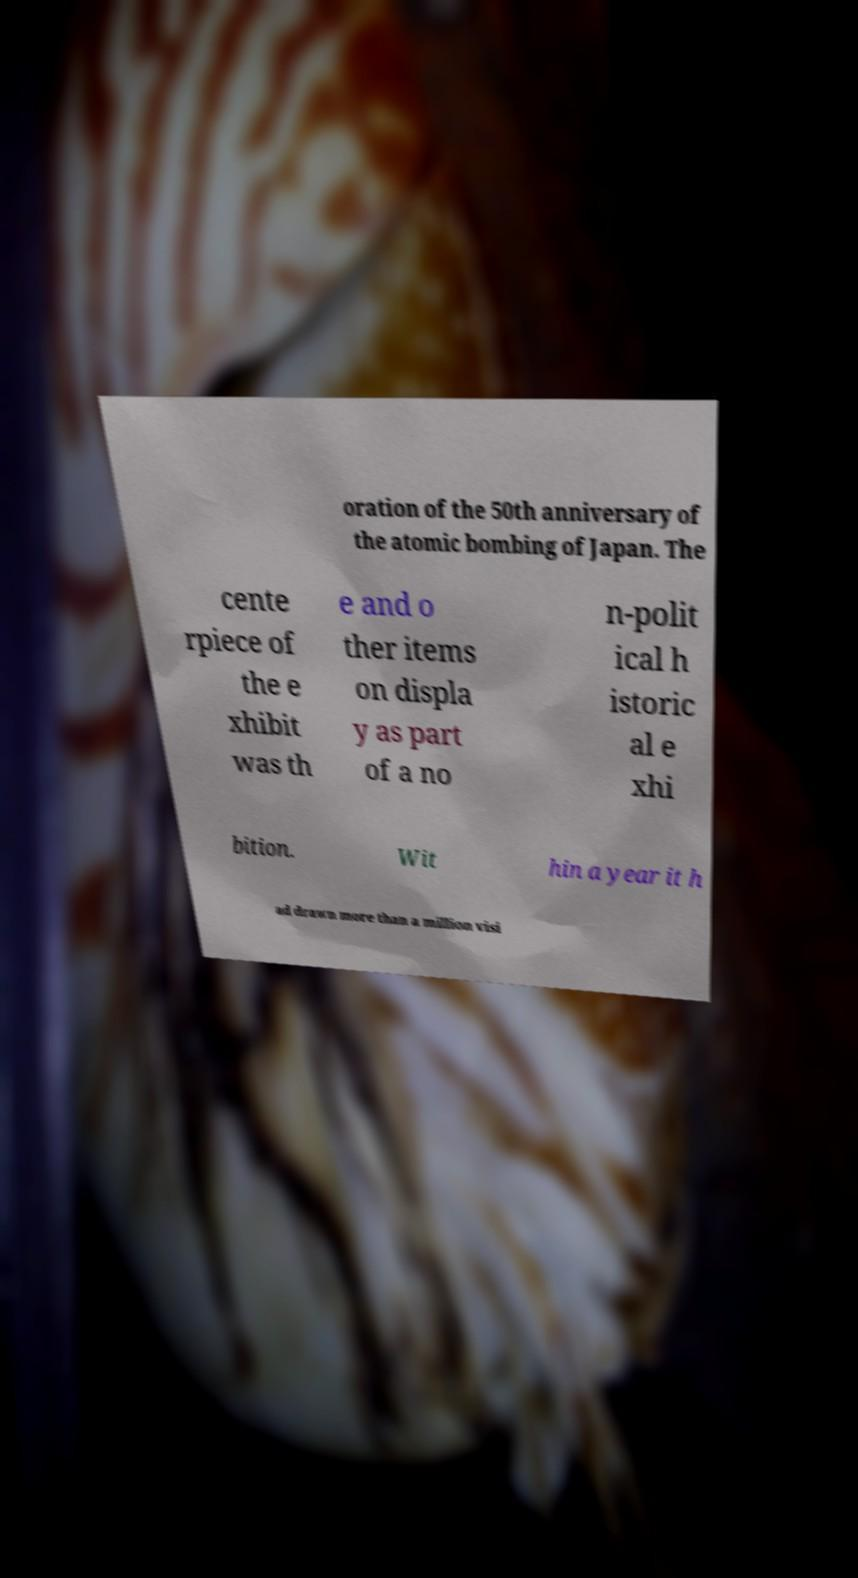For documentation purposes, I need the text within this image transcribed. Could you provide that? oration of the 50th anniversary of the atomic bombing of Japan. The cente rpiece of the e xhibit was th e and o ther items on displa y as part of a no n-polit ical h istoric al e xhi bition. Wit hin a year it h ad drawn more than a million visi 